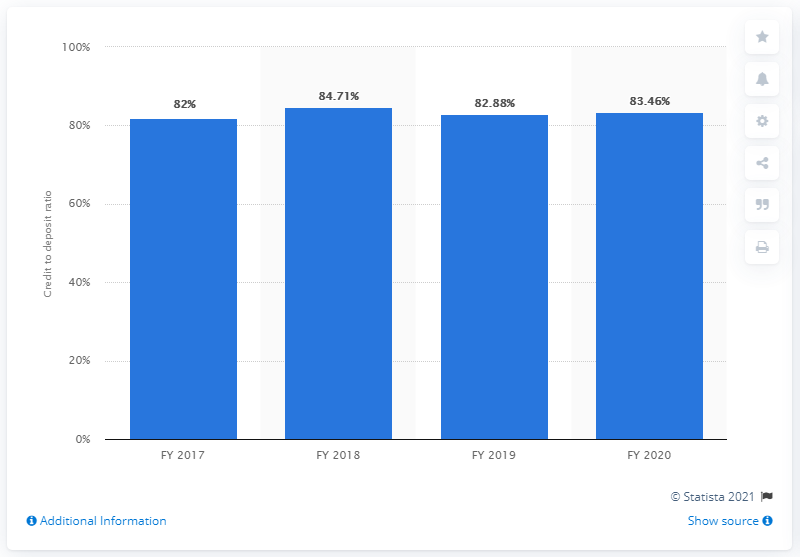Indicate a few pertinent items in this graphic. In fiscal year 2020, the credit to deposit ratio of DCB Bank in India was 83.46. This indicates that the bank had 83.46 Rupees worth of loans and advances for every 100 Rupees worth of deposits it held. 